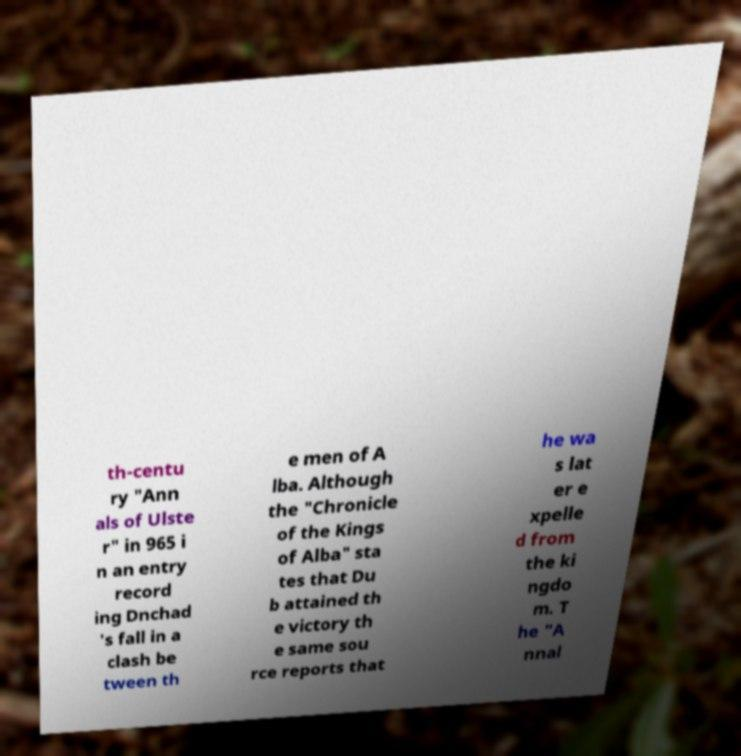Could you extract and type out the text from this image? th-centu ry "Ann als of Ulste r" in 965 i n an entry record ing Dnchad 's fall in a clash be tween th e men of A lba. Although the "Chronicle of the Kings of Alba" sta tes that Du b attained th e victory th e same sou rce reports that he wa s lat er e xpelle d from the ki ngdo m. T he "A nnal 